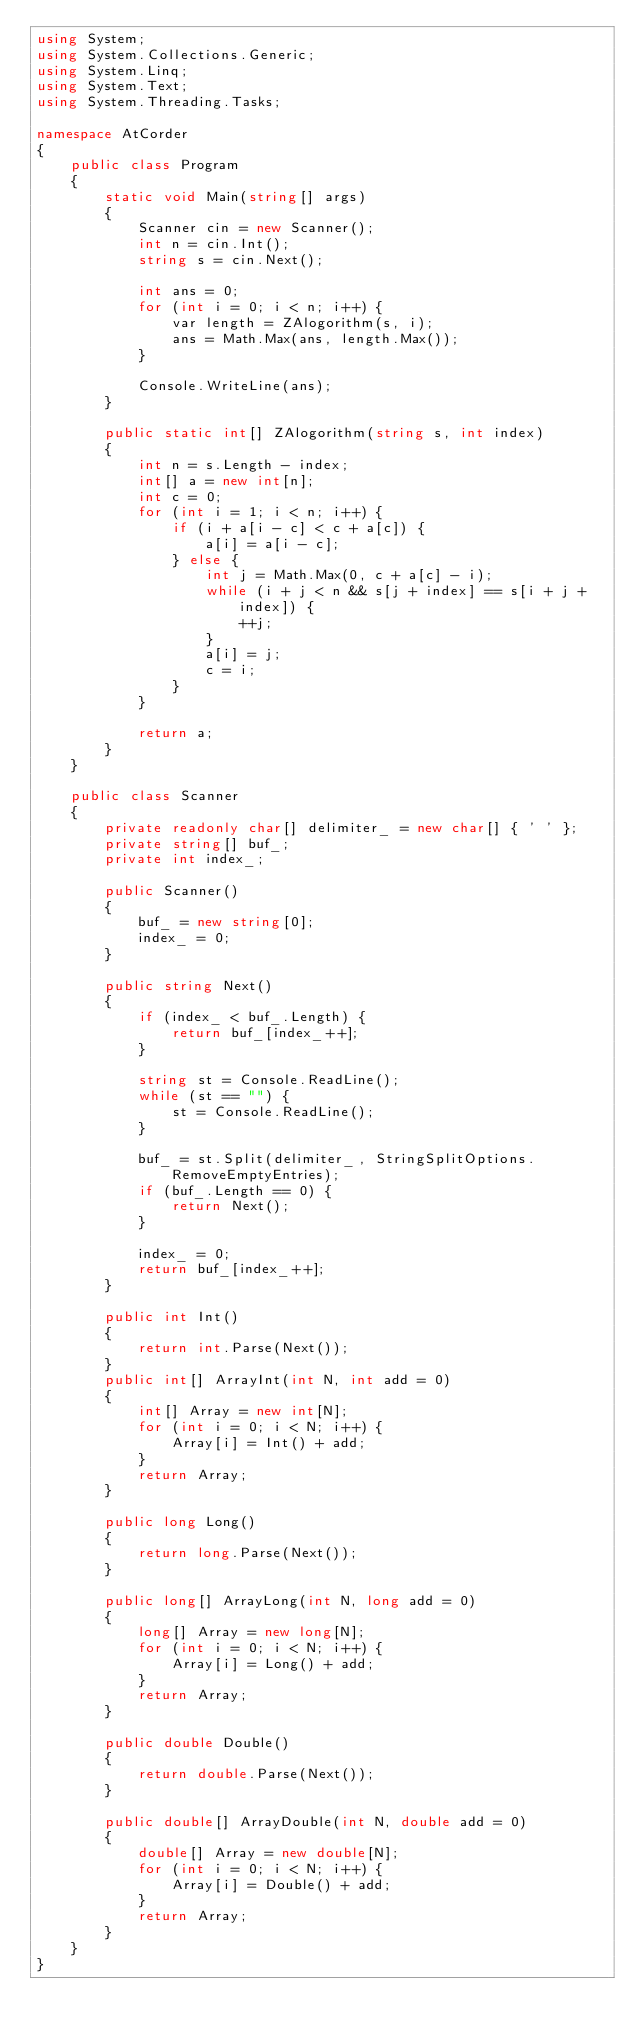<code> <loc_0><loc_0><loc_500><loc_500><_C#_>using System;
using System.Collections.Generic;
using System.Linq;
using System.Text;
using System.Threading.Tasks;

namespace AtCorder
{
	public class Program
	{
		static void Main(string[] args)
		{
			Scanner cin = new Scanner();
			int n = cin.Int();
			string s = cin.Next();

			int ans = 0;
			for (int i = 0; i < n; i++) {
				var length = ZAlogorithm(s, i);
				ans = Math.Max(ans, length.Max());
			}

			Console.WriteLine(ans);
		}

		public static int[] ZAlogorithm(string s, int index)
		{
			int n = s.Length - index;
			int[] a = new int[n];
			int c = 0;
			for (int i = 1; i < n; i++) {
				if (i + a[i - c] < c + a[c]) {
					a[i] = a[i - c];
				} else {
					int j = Math.Max(0, c + a[c] - i);
					while (i + j < n && s[j + index] == s[i + j + index]) {
						++j;
					}
					a[i] = j;
					c = i;
				}
			}

			return a;
		}
	}

	public class Scanner
	{
		private readonly char[] delimiter_ = new char[] { ' ' };
		private string[] buf_;
		private int index_;

		public Scanner()
		{
			buf_ = new string[0];
			index_ = 0;
		}

		public string Next()
		{
			if (index_ < buf_.Length) {
				return buf_[index_++];
			}

			string st = Console.ReadLine();
			while (st == "") {
				st = Console.ReadLine();
			}

			buf_ = st.Split(delimiter_, StringSplitOptions.RemoveEmptyEntries);
			if (buf_.Length == 0) {
				return Next();
			}

			index_ = 0;
			return buf_[index_++];
		}

		public int Int()
		{
			return int.Parse(Next());
		}
		public int[] ArrayInt(int N, int add = 0)
		{
			int[] Array = new int[N];
			for (int i = 0; i < N; i++) {
				Array[i] = Int() + add;
			}
			return Array;
		}

		public long Long()
		{
			return long.Parse(Next());
		}

		public long[] ArrayLong(int N, long add = 0)
		{
			long[] Array = new long[N];
			for (int i = 0; i < N; i++) {
				Array[i] = Long() + add;
			}
			return Array;
		}

		public double Double()
		{
			return double.Parse(Next());
		}

		public double[] ArrayDouble(int N, double add = 0)
		{
			double[] Array = new double[N];
			for (int i = 0; i < N; i++) {
				Array[i] = Double() + add;
			}
			return Array;
		}
	}
}</code> 